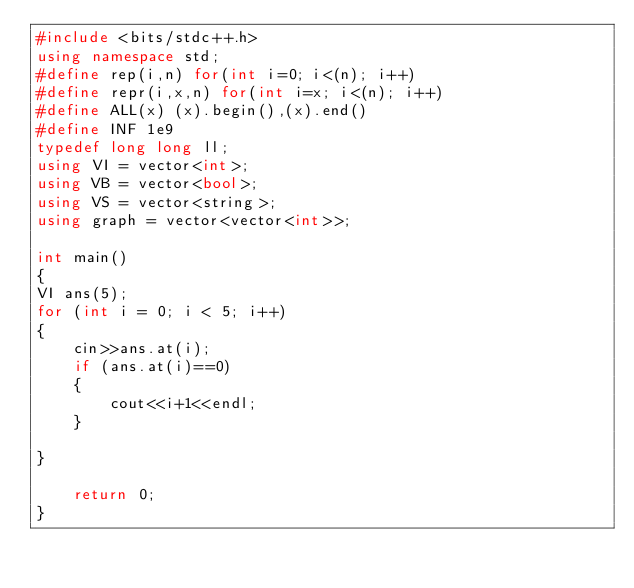Convert code to text. <code><loc_0><loc_0><loc_500><loc_500><_C++_>#include <bits/stdc++.h>
using namespace std;
#define rep(i,n) for(int i=0; i<(n); i++)
#define repr(i,x,n) for(int i=x; i<(n); i++)
#define ALL(x) (x).begin(),(x).end()
#define INF 1e9
typedef long long ll;
using VI = vector<int>;
using VB = vector<bool>;
using VS = vector<string>;
using graph = vector<vector<int>>;

int main()
{
VI ans(5);
for (int i = 0; i < 5; i++)
{
    cin>>ans.at(i);
    if (ans.at(i)==0)
    {
        cout<<i+1<<endl;
    }
    
}

    return 0;
}</code> 